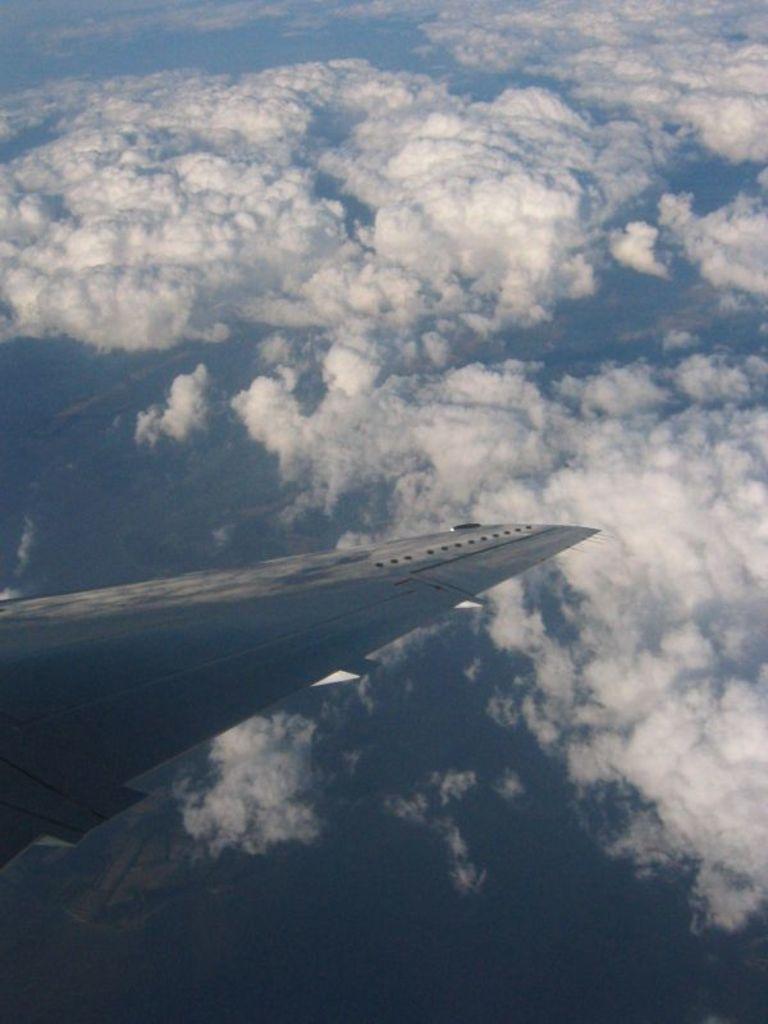Please provide a concise description of this image. In this picture we can see an airplane wing and in the background we can see sky with clouds. 